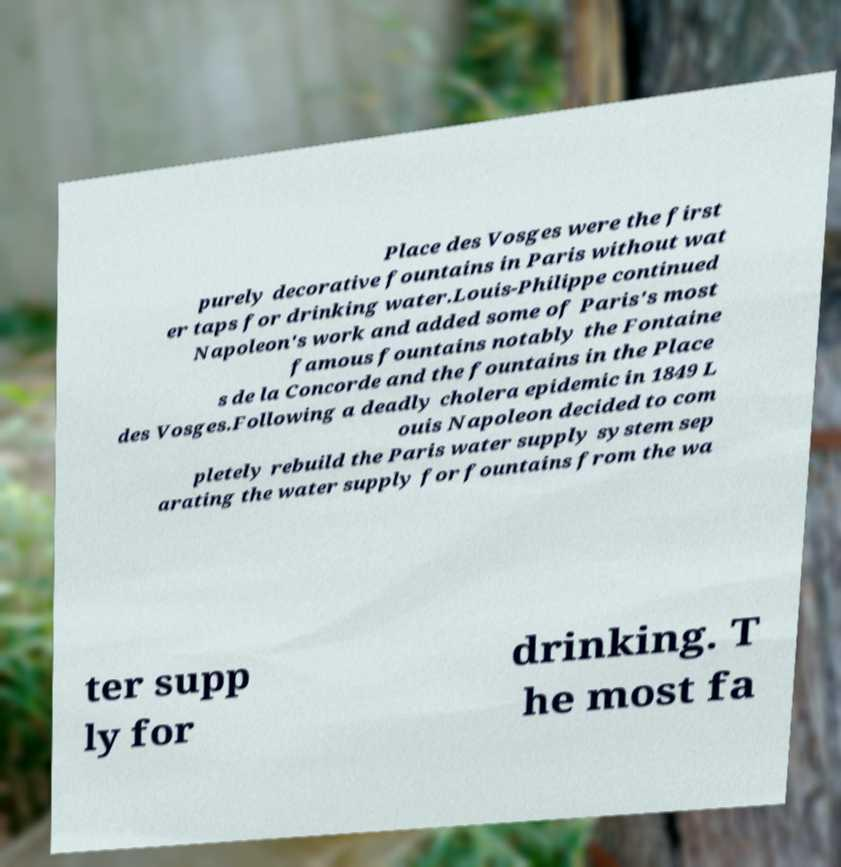Please identify and transcribe the text found in this image. Place des Vosges were the first purely decorative fountains in Paris without wat er taps for drinking water.Louis-Philippe continued Napoleon's work and added some of Paris's most famous fountains notably the Fontaine s de la Concorde and the fountains in the Place des Vosges.Following a deadly cholera epidemic in 1849 L ouis Napoleon decided to com pletely rebuild the Paris water supply system sep arating the water supply for fountains from the wa ter supp ly for drinking. T he most fa 